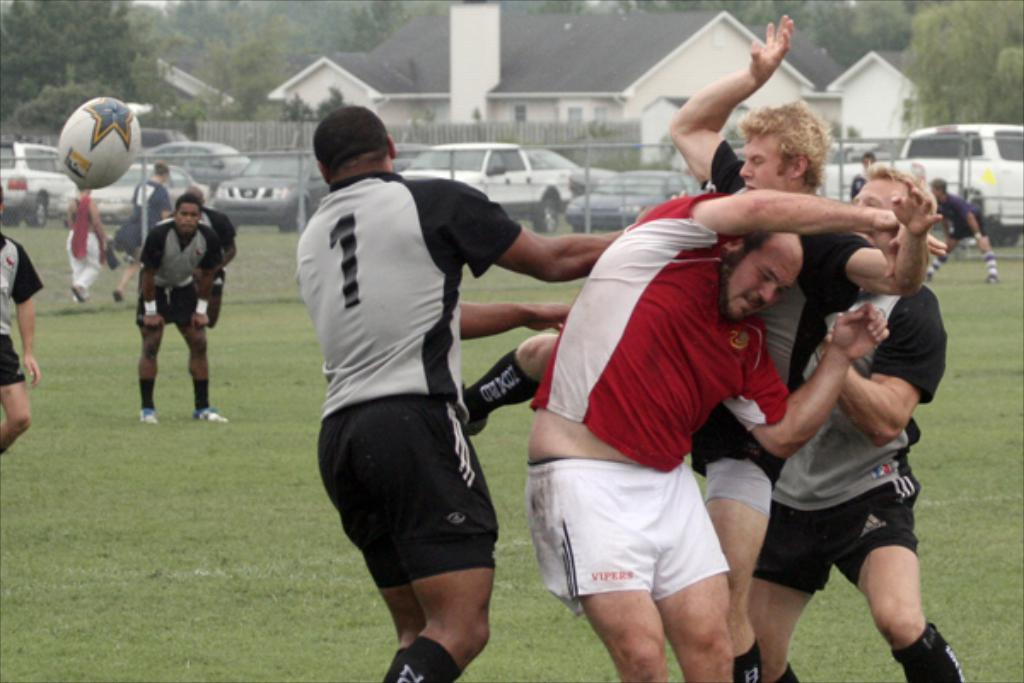How many people can be seen in the image? There are a few people in the image. What type of surface covers the ground in the image? The ground is covered with grass. What types of vehicles are present in the image? There are vehicles in the image. What type of structures can be seen in the image? There are houses in the image. What type of vegetation is present in the image? There are trees in the image. What type of barrier can be seen in the image? There is a fence in the image. What object is present that might be used for playing? There is a ball in the image. What type of mountain can be seen in the image? There is no mountain present in the image. What type of current is flowing through the image? There is no current present in the image, as it is not a water-based environment. 